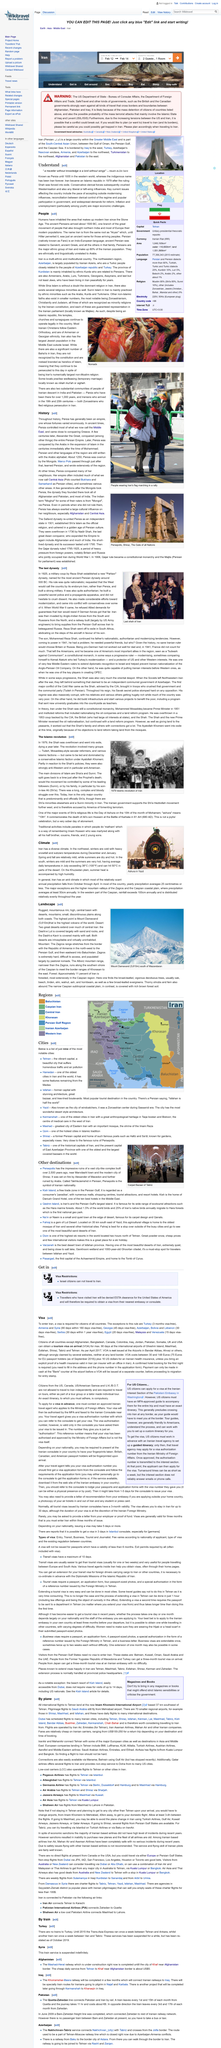Highlight a few significant elements in this photo. In 1935, the Western world recognized Iran as Persia. Iran was previously known as Persia. Iran became an Islamic republic in 1979. 